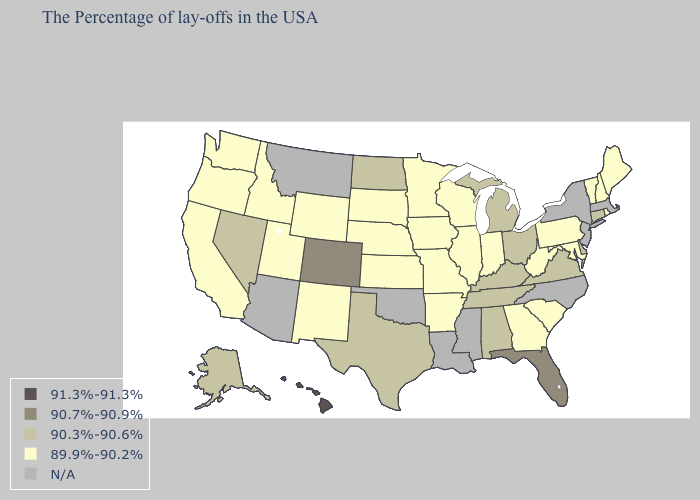Does Hawaii have the lowest value in the West?
Short answer required. No. Which states have the highest value in the USA?
Short answer required. Hawaii. Among the states that border New York , does Connecticut have the lowest value?
Answer briefly. No. Name the states that have a value in the range 90.3%-90.6%?
Concise answer only. Connecticut, Delaware, Virginia, Ohio, Michigan, Kentucky, Alabama, Tennessee, Texas, North Dakota, Nevada, Alaska. Name the states that have a value in the range 91.3%-91.3%?
Concise answer only. Hawaii. What is the value of Arkansas?
Quick response, please. 89.9%-90.2%. What is the value of Missouri?
Concise answer only. 89.9%-90.2%. Which states have the highest value in the USA?
Short answer required. Hawaii. What is the value of Colorado?
Short answer required. 90.7%-90.9%. Does Hawaii have the highest value in the USA?
Quick response, please. Yes. Name the states that have a value in the range 91.3%-91.3%?
Be succinct. Hawaii. What is the value of Arkansas?
Be succinct. 89.9%-90.2%. What is the highest value in states that border Michigan?
Keep it brief. 90.3%-90.6%. What is the lowest value in the USA?
Give a very brief answer. 89.9%-90.2%. Name the states that have a value in the range 91.3%-91.3%?
Be succinct. Hawaii. 